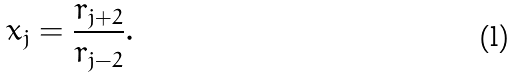<formula> <loc_0><loc_0><loc_500><loc_500>x _ { j } = \frac { r _ { j + 2 } } { r _ { j - 2 } } .</formula> 